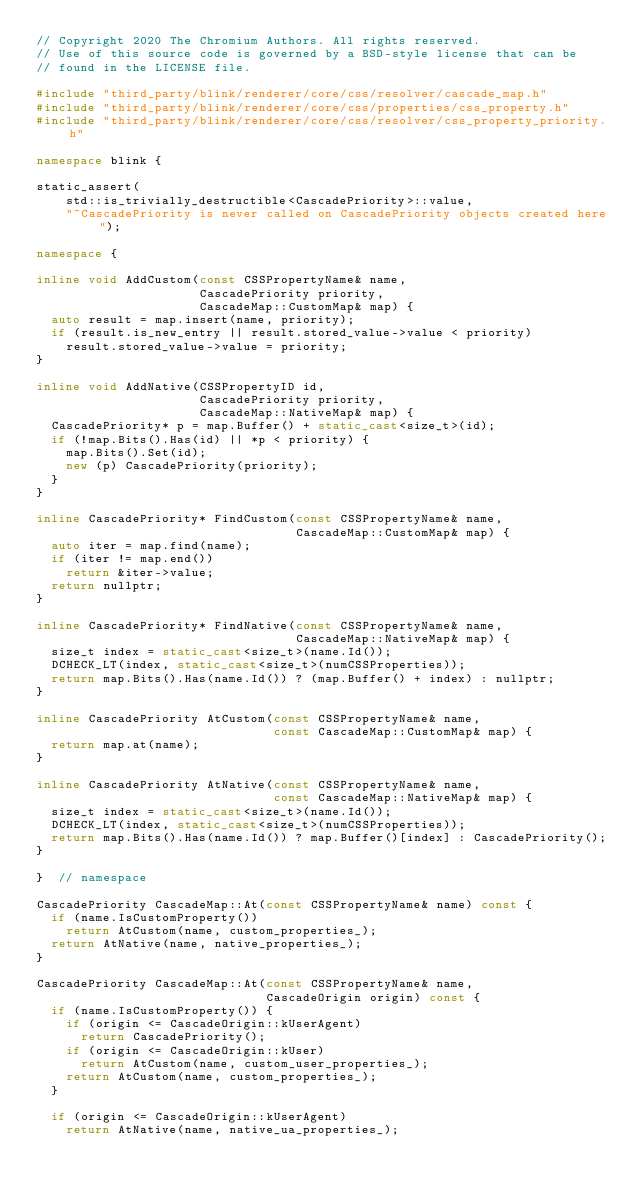Convert code to text. <code><loc_0><loc_0><loc_500><loc_500><_C++_>// Copyright 2020 The Chromium Authors. All rights reserved.
// Use of this source code is governed by a BSD-style license that can be
// found in the LICENSE file.

#include "third_party/blink/renderer/core/css/resolver/cascade_map.h"
#include "third_party/blink/renderer/core/css/properties/css_property.h"
#include "third_party/blink/renderer/core/css/resolver/css_property_priority.h"

namespace blink {

static_assert(
    std::is_trivially_destructible<CascadePriority>::value,
    "~CascadePriority is never called on CascadePriority objects created here");

namespace {

inline void AddCustom(const CSSPropertyName& name,
                      CascadePriority priority,
                      CascadeMap::CustomMap& map) {
  auto result = map.insert(name, priority);
  if (result.is_new_entry || result.stored_value->value < priority)
    result.stored_value->value = priority;
}

inline void AddNative(CSSPropertyID id,
                      CascadePriority priority,
                      CascadeMap::NativeMap& map) {
  CascadePriority* p = map.Buffer() + static_cast<size_t>(id);
  if (!map.Bits().Has(id) || *p < priority) {
    map.Bits().Set(id);
    new (p) CascadePriority(priority);
  }
}

inline CascadePriority* FindCustom(const CSSPropertyName& name,
                                   CascadeMap::CustomMap& map) {
  auto iter = map.find(name);
  if (iter != map.end())
    return &iter->value;
  return nullptr;
}

inline CascadePriority* FindNative(const CSSPropertyName& name,
                                   CascadeMap::NativeMap& map) {
  size_t index = static_cast<size_t>(name.Id());
  DCHECK_LT(index, static_cast<size_t>(numCSSProperties));
  return map.Bits().Has(name.Id()) ? (map.Buffer() + index) : nullptr;
}

inline CascadePriority AtCustom(const CSSPropertyName& name,
                                const CascadeMap::CustomMap& map) {
  return map.at(name);
}

inline CascadePriority AtNative(const CSSPropertyName& name,
                                const CascadeMap::NativeMap& map) {
  size_t index = static_cast<size_t>(name.Id());
  DCHECK_LT(index, static_cast<size_t>(numCSSProperties));
  return map.Bits().Has(name.Id()) ? map.Buffer()[index] : CascadePriority();
}

}  // namespace

CascadePriority CascadeMap::At(const CSSPropertyName& name) const {
  if (name.IsCustomProperty())
    return AtCustom(name, custom_properties_);
  return AtNative(name, native_properties_);
}

CascadePriority CascadeMap::At(const CSSPropertyName& name,
                               CascadeOrigin origin) const {
  if (name.IsCustomProperty()) {
    if (origin <= CascadeOrigin::kUserAgent)
      return CascadePriority();
    if (origin <= CascadeOrigin::kUser)
      return AtCustom(name, custom_user_properties_);
    return AtCustom(name, custom_properties_);
  }

  if (origin <= CascadeOrigin::kUserAgent)
    return AtNative(name, native_ua_properties_);</code> 